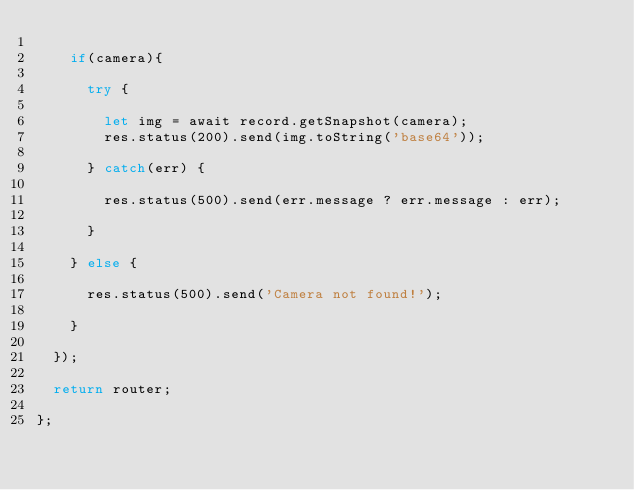Convert code to text. <code><loc_0><loc_0><loc_500><loc_500><_JavaScript_>    
    if(camera){
    
      try {
        
        let img = await record.getSnapshot(camera);
        res.status(200).send(img.toString('base64'));
        
      } catch(err) {
        
        res.status(500).send(err.message ? err.message : err);
        
      }
    
    } else {
    
      res.status(500).send('Camera not found!');
    
    }
           
  });
  
  return router;

};</code> 